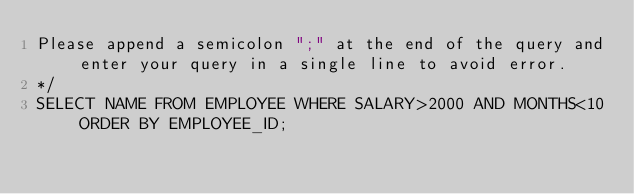<code> <loc_0><loc_0><loc_500><loc_500><_SQL_>Please append a semicolon ";" at the end of the query and enter your query in a single line to avoid error.
*/
SELECT NAME FROM EMPLOYEE WHERE SALARY>2000 AND MONTHS<10 ORDER BY EMPLOYEE_ID;</code> 